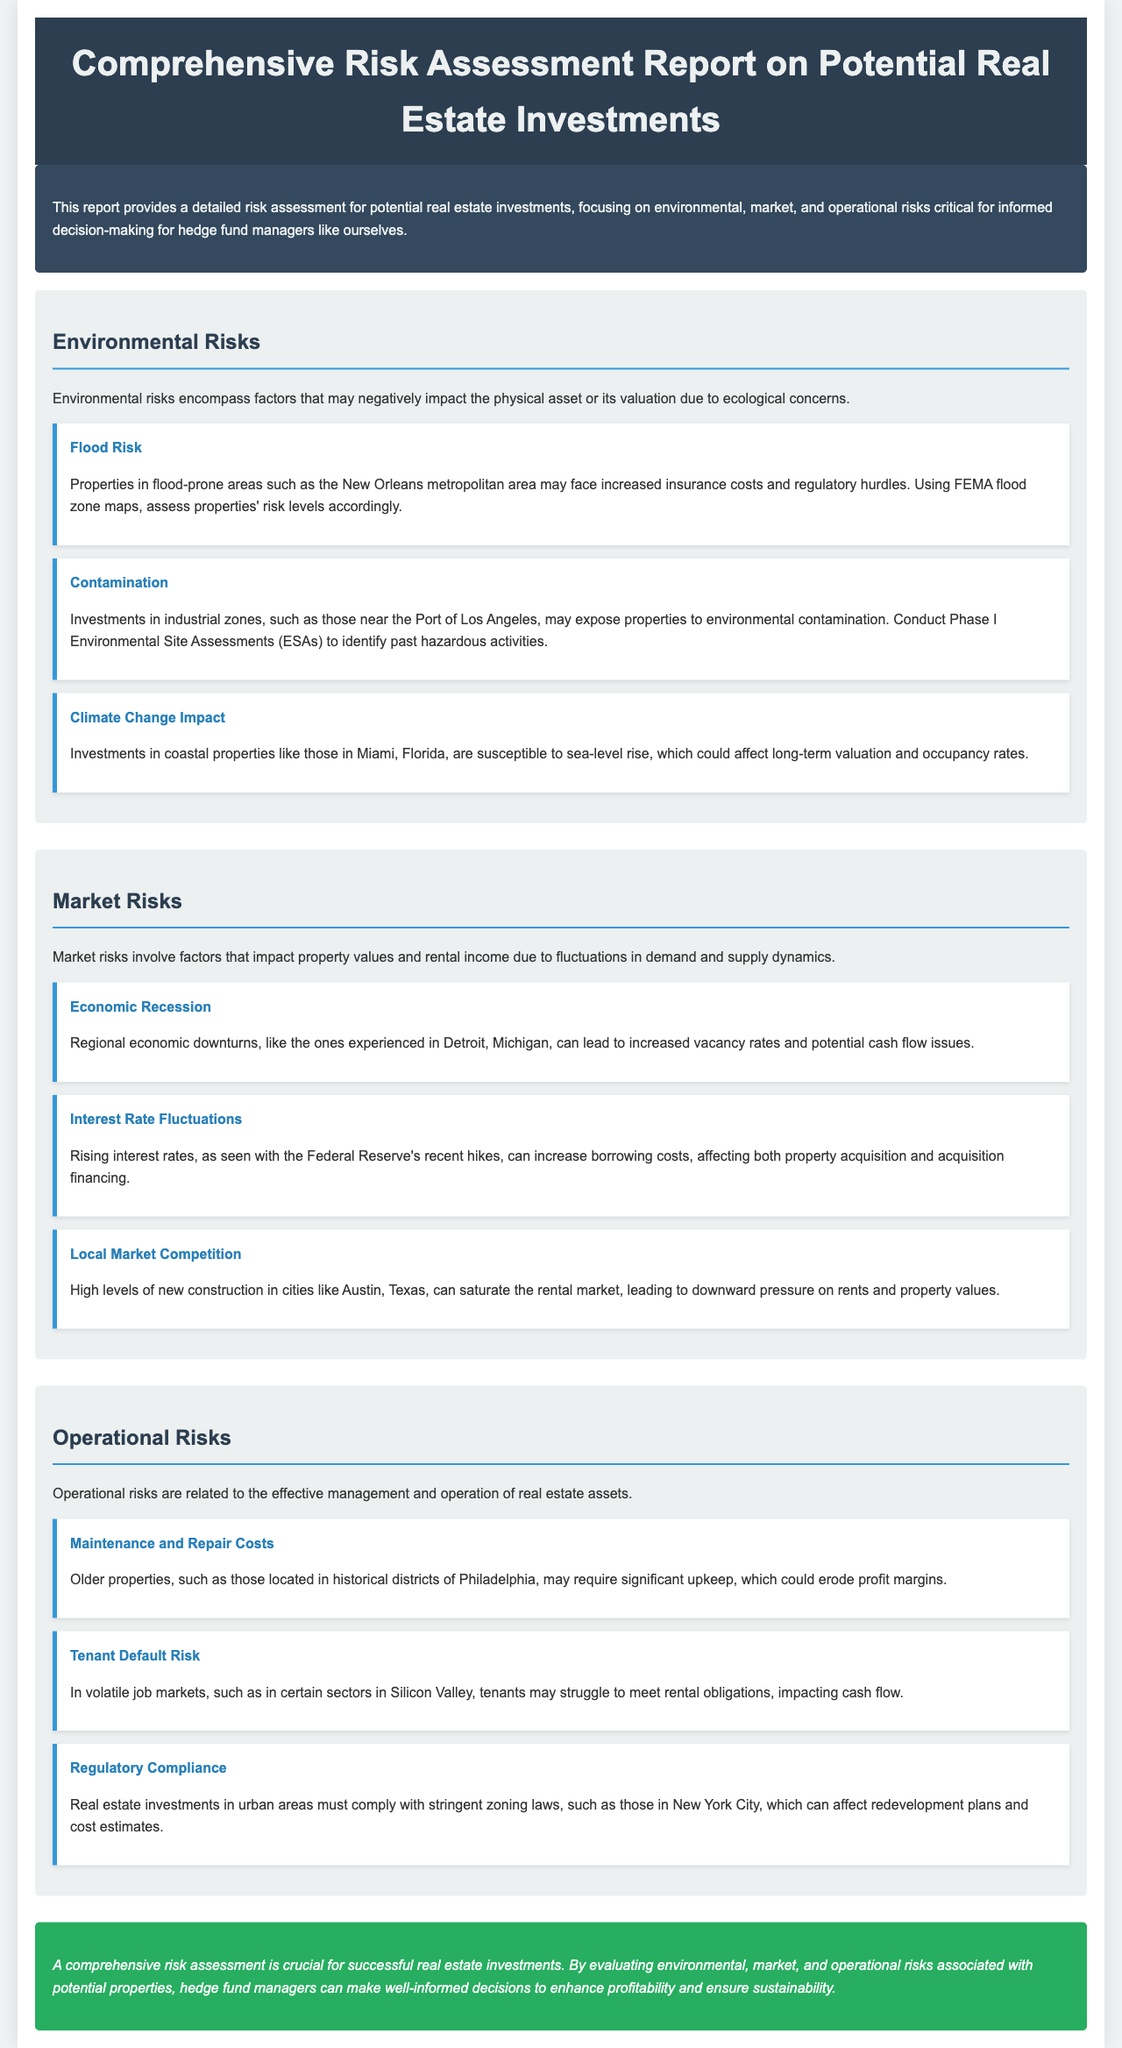What are the three types of risks highlighted in the report? The document categorizes risks into environmental, market, and operational risks.
Answer: Environmental, market, operational What location is mentioned as being prone to flood risk? The report states that properties in the New Orleans metropolitan area may face flood risk.
Answer: New Orleans metropolitan area What assessment is recommended for identifying environmental contamination? The report suggests conducting Phase I Environmental Site Assessments (ESAs) for properties in industrial zones.
Answer: Phase I Environmental Site Assessments What economic event can lead to increased vacancy rates according to the report? The document mentions that a regional economic downturn can lead to increased vacancy rates.
Answer: Economic recession Which city is noted for high levels of new construction impacting local market competition? The report highlights Austin, Texas, as facing saturation in the rental market due to high construction levels.
Answer: Austin, Texas How does the report suggest that climate change may affect coastal investments? It states that coastal properties, like those in Miami, are susceptible to sea-level rise affecting valuation and occupancy rates.
Answer: Sea-level rise What operational risk involves the potential for tenant financial difficulties? The document refers to tenant default risk as an operational risk in volatile job markets.
Answer: Tenant default risk What is a major regulatory concern for real estate investments in urban areas? The report notes that compliance with stringent zoning laws is a critical concern for urban real estate investments.
Answer: Zoning laws 